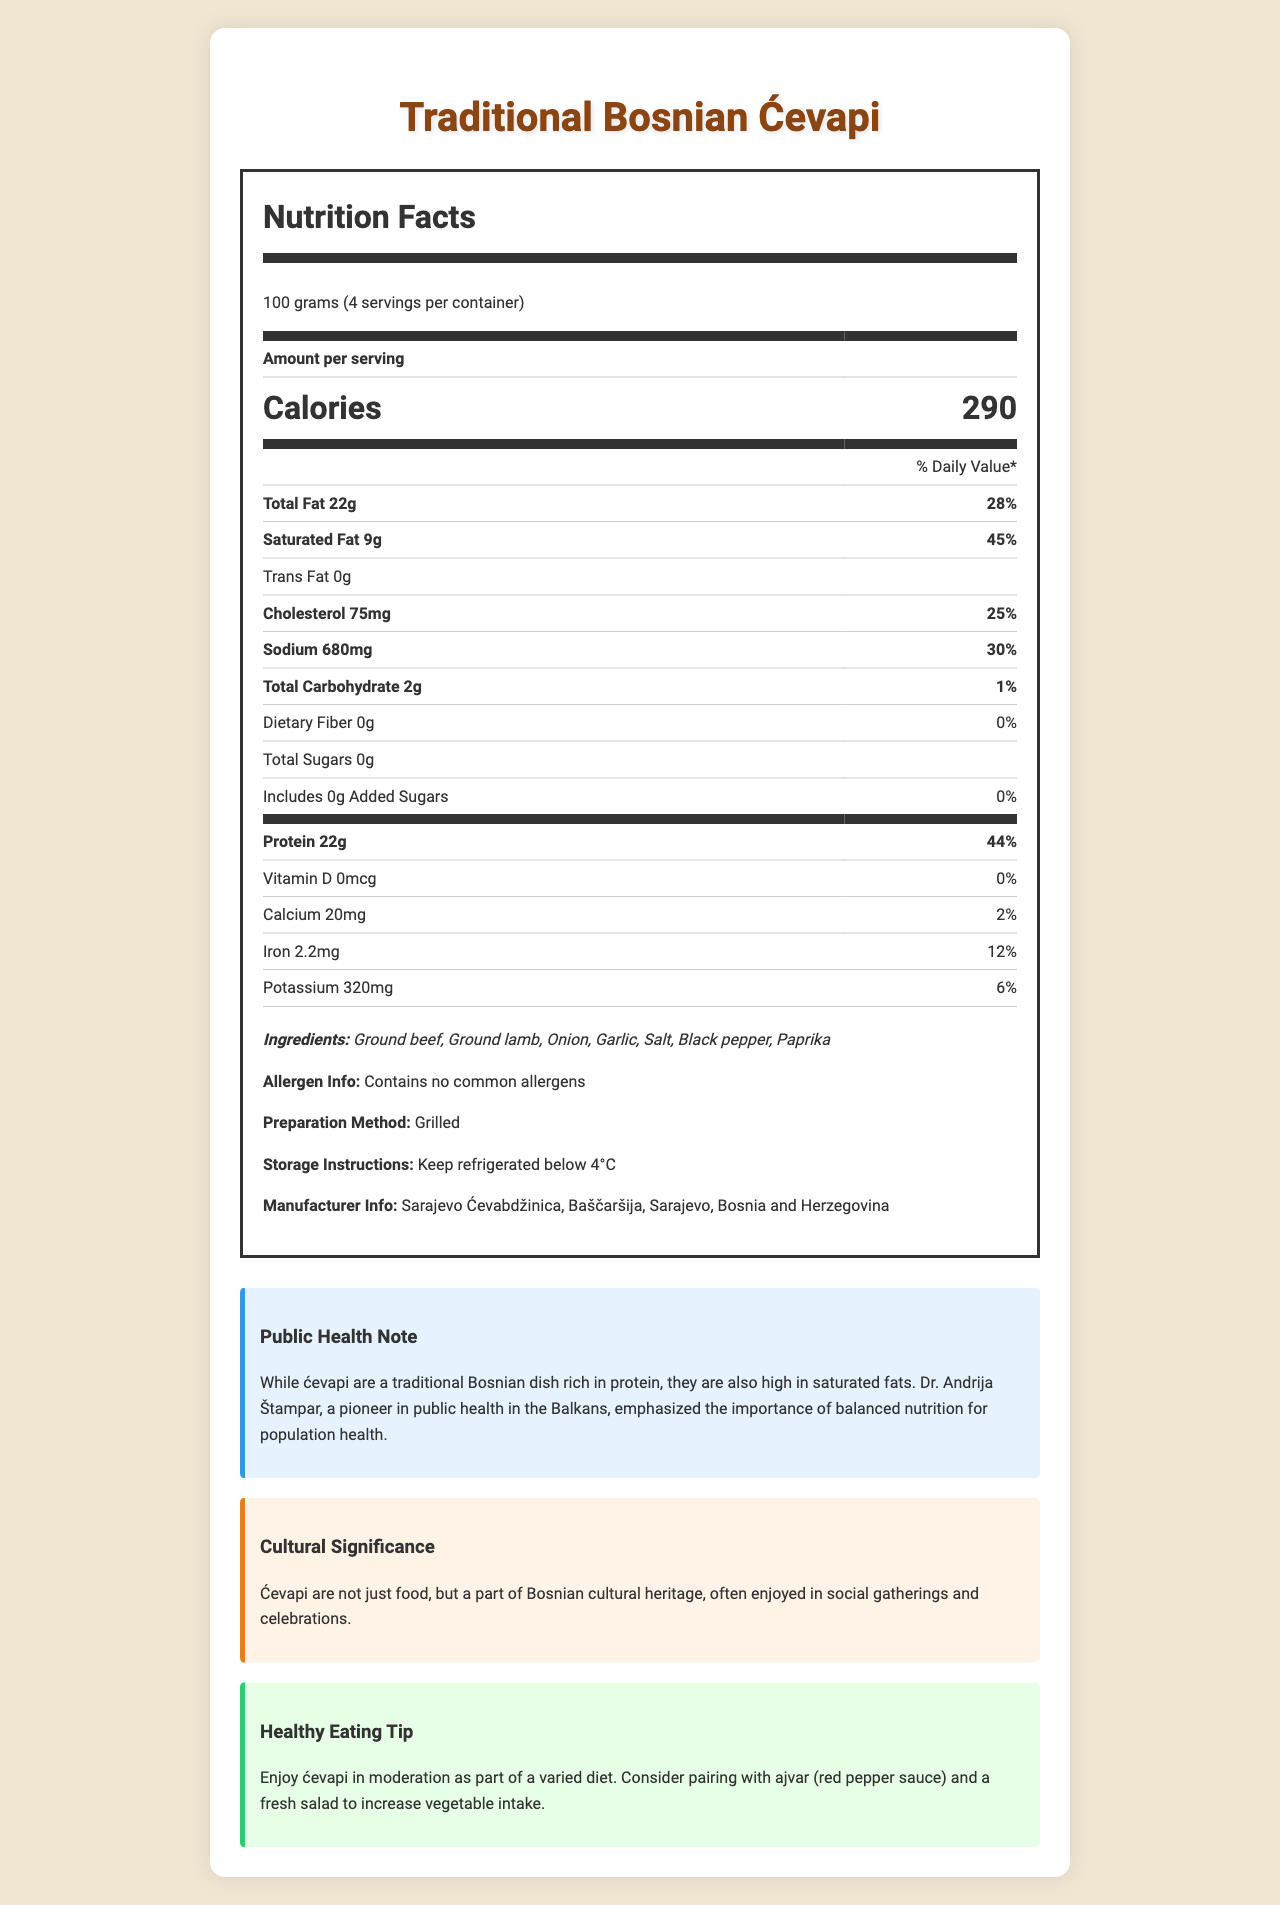what is the serving size of Traditional Bosnian Ćevapi? According to the document, the serving size of Traditional Bosnian Ćevapi is 100 grams.
Answer: 100 grams how much protein is in one serving of Traditional Bosnian Ćevapi? The protein content per serving is listed as 22 grams.
Answer: 22g what percent of the daily value of protein does one serving of Traditional Bosnian Ćevapi provide? The document states that one serving provides 44% of the daily value of protein.
Answer: 44% how much saturated fat is there in one serving? The amount of saturated fat per serving is 9 grams.
Answer: 9g what is the percent daily value of saturated fat in one serving? The percent daily value of saturated fat in one serving is listed as 45%.
Answer: 45% which nutrient has the highest percent daily value per serving? A. Cholesterol B. Sodium C. Protein D. Total Fat Protein has the highest percent daily value per serving at 44%, compared to cholesterol (25%), sodium (30%), and total fat (28%).
Answer: C. Protein how many total servings are in one container? A. 2 B. 3 C. 4 D. 5 The document states that there are 4 servings per container.
Answer: C. 4 is ćevapi high in protein? The nutrition label and the claim highlight state that ćevapi is high in protein, which is essential for muscle growth and repair.
Answer: Yes summarize the main idea of the nutrition facts label for Traditional Bosnian Ćevapi The nutrition facts label for Traditional Bosnian Ćevapi includes detailed nutritional information, emphasizing its high protein content and the caution for saturated fat intake. It includes health notes and cultural significance, encouraging balanced consumption.
Answer: The document provides the nutrition facts for Traditional Bosnian Ćevapi, including serving size, calories, and detailed nutrient information. It highlights that ćevapi are high in protein but also contain a significant amount of saturated fat. Public health notes and healthy eating tips are provided, emphasizing the importance of balanced nutrition while enjoying this traditional dish. The document also notes its cultural significance in Bosnian heritage. what are the ingredients listed for Traditional Bosnian Ćevapi? The document lists these as the ingredients in Traditional Bosnian Ćevapi.
Answer: Ground beef, Ground lamb, Onion, Garlic, Salt, Black pepper, Paprika how many grams of carbohydrates are in one serving? The amount of total carbohydrates per serving is 2 grams.
Answer: 2g what is the preparation method for Traditional Bosnian Ćevapi? The document specifies that Traditional Bosnian Ćevapi is prepared by grilling.
Answer: Grilled what is the storage instruction for Traditional Bosnian Ćevapi? The document instructs to keep the ćevapi refrigerated below 4°C.
Answer: Keep refrigerated below 4°C what health concern does the public health note highlight about consuming ćevapi? The public health note emphasizes that while ćevapi are rich in protein, they are also high in saturated fats, which should be considered for balanced nutrition.
Answer: High in saturated fats how much trans fat is in one serving of Traditional Bosnian Ćevapi? The nutrition label indicates that there is no trans fat in one serving of Traditional Bosnian Ćevapi.
Answer: 0g does the label provide information about any allergens? The document mentions that there are no common allergens in Traditional Bosnian Ćevapi.
Answer: Yes how much calcium does one serving contain? The amount of calcium per serving is listed as 20 milligrams.
Answer: 20mg who is considered a pioneer in public health in the Balkans as mentioned in the document? The public health note in the document mentions Dr. Andrija Štampar as a pioneer in public health in the Balkans.
Answer: Dr. Andrija Štampar who is the manufacturer of Traditional Bosnian Ćevapi? The document lists Sarajevo Ćevabdžinica, Baščaršija, Sarajevo, Bosnia and Herzegovina as the manufacturer.
Answer: Sarajevo Ćevabdžinica, Baščaršija, Sarajevo, Bosnia and Herzegovina what is the total amount of fat in one serving? The nutrition label states that one serving contains a total of 22 grams of fat.
Answer: 22g where can I purchase Traditional Bosnian Ćevapi? The document does not provide purchase information or locations for Traditional Bosnian Ćevapi.
Answer: Not enough information 